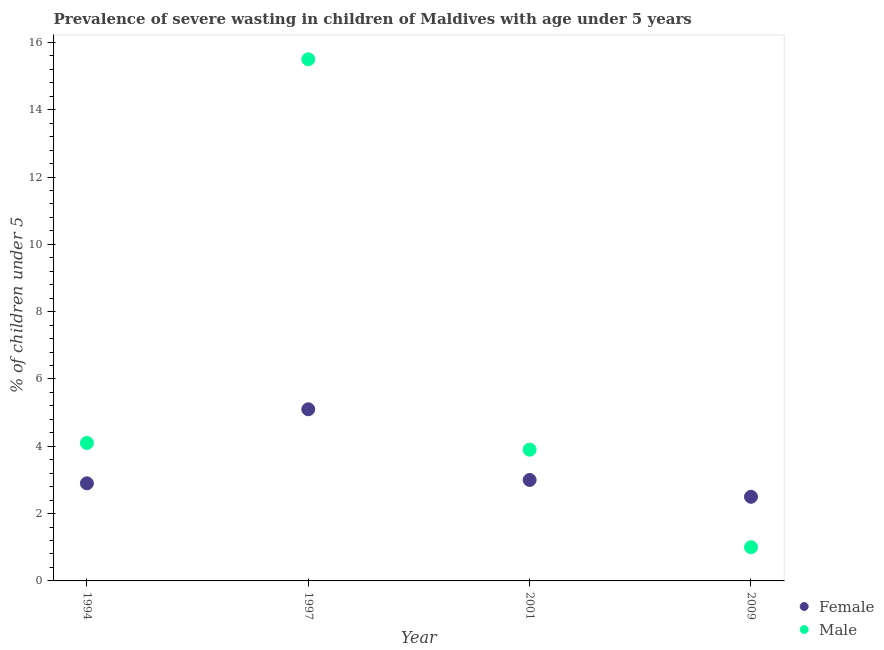What is the percentage of undernourished female children in 1997?
Your response must be concise. 5.1. Across all years, what is the maximum percentage of undernourished female children?
Your answer should be compact. 5.1. In which year was the percentage of undernourished male children minimum?
Provide a succinct answer. 2009. What is the difference between the percentage of undernourished male children in 1994 and that in 1997?
Offer a terse response. -11.4. What is the difference between the percentage of undernourished female children in 1997 and the percentage of undernourished male children in 2001?
Your response must be concise. 1.2. What is the average percentage of undernourished female children per year?
Offer a very short reply. 3.38. In the year 2009, what is the difference between the percentage of undernourished female children and percentage of undernourished male children?
Offer a terse response. 1.5. What is the ratio of the percentage of undernourished female children in 1994 to that in 2001?
Provide a succinct answer. 0.97. Is the percentage of undernourished male children in 1997 less than that in 2001?
Your response must be concise. No. Is the difference between the percentage of undernourished female children in 1994 and 2009 greater than the difference between the percentage of undernourished male children in 1994 and 2009?
Your answer should be compact. No. What is the difference between the highest and the second highest percentage of undernourished female children?
Provide a short and direct response. 2.1. What is the difference between the highest and the lowest percentage of undernourished female children?
Your response must be concise. 2.6. In how many years, is the percentage of undernourished male children greater than the average percentage of undernourished male children taken over all years?
Your response must be concise. 1. Does the percentage of undernourished male children monotonically increase over the years?
Give a very brief answer. No. Is the percentage of undernourished female children strictly greater than the percentage of undernourished male children over the years?
Make the answer very short. No. How many dotlines are there?
Offer a terse response. 2. How many years are there in the graph?
Give a very brief answer. 4. What is the difference between two consecutive major ticks on the Y-axis?
Keep it short and to the point. 2. How many legend labels are there?
Provide a short and direct response. 2. What is the title of the graph?
Your answer should be compact. Prevalence of severe wasting in children of Maldives with age under 5 years. Does "Electricity and heat production" appear as one of the legend labels in the graph?
Your answer should be compact. No. What is the label or title of the Y-axis?
Your answer should be very brief.  % of children under 5. What is the  % of children under 5 in Female in 1994?
Provide a short and direct response. 2.9. What is the  % of children under 5 of Male in 1994?
Make the answer very short. 4.1. What is the  % of children under 5 of Female in 1997?
Your response must be concise. 5.1. What is the  % of children under 5 of Male in 1997?
Make the answer very short. 15.5. What is the  % of children under 5 of Male in 2001?
Make the answer very short. 3.9. Across all years, what is the maximum  % of children under 5 in Female?
Your answer should be very brief. 5.1. Across all years, what is the maximum  % of children under 5 in Male?
Offer a very short reply. 15.5. Across all years, what is the minimum  % of children under 5 in Male?
Give a very brief answer. 1. What is the total  % of children under 5 of Female in the graph?
Provide a short and direct response. 13.5. What is the total  % of children under 5 of Male in the graph?
Provide a short and direct response. 24.5. What is the difference between the  % of children under 5 in Male in 1994 and that in 1997?
Give a very brief answer. -11.4. What is the difference between the  % of children under 5 in Male in 1994 and that in 2009?
Give a very brief answer. 3.1. What is the difference between the  % of children under 5 in Male in 1997 and that in 2009?
Keep it short and to the point. 14.5. What is the difference between the  % of children under 5 in Male in 2001 and that in 2009?
Offer a very short reply. 2.9. What is the average  % of children under 5 of Female per year?
Your answer should be compact. 3.38. What is the average  % of children under 5 of Male per year?
Keep it short and to the point. 6.12. In the year 1994, what is the difference between the  % of children under 5 in Female and  % of children under 5 in Male?
Provide a short and direct response. -1.2. In the year 2009, what is the difference between the  % of children under 5 of Female and  % of children under 5 of Male?
Your answer should be compact. 1.5. What is the ratio of the  % of children under 5 in Female in 1994 to that in 1997?
Give a very brief answer. 0.57. What is the ratio of the  % of children under 5 of Male in 1994 to that in 1997?
Your answer should be very brief. 0.26. What is the ratio of the  % of children under 5 of Female in 1994 to that in 2001?
Ensure brevity in your answer.  0.97. What is the ratio of the  % of children under 5 in Male in 1994 to that in 2001?
Offer a terse response. 1.05. What is the ratio of the  % of children under 5 of Female in 1994 to that in 2009?
Keep it short and to the point. 1.16. What is the ratio of the  % of children under 5 in Female in 1997 to that in 2001?
Give a very brief answer. 1.7. What is the ratio of the  % of children under 5 in Male in 1997 to that in 2001?
Your answer should be compact. 3.97. What is the ratio of the  % of children under 5 in Female in 1997 to that in 2009?
Give a very brief answer. 2.04. What is the ratio of the  % of children under 5 of Male in 1997 to that in 2009?
Offer a very short reply. 15.5. What is the ratio of the  % of children under 5 in Female in 2001 to that in 2009?
Your response must be concise. 1.2. What is the ratio of the  % of children under 5 in Male in 2001 to that in 2009?
Give a very brief answer. 3.9. What is the difference between the highest and the second highest  % of children under 5 in Female?
Offer a terse response. 2.1. What is the difference between the highest and the lowest  % of children under 5 of Male?
Your answer should be very brief. 14.5. 